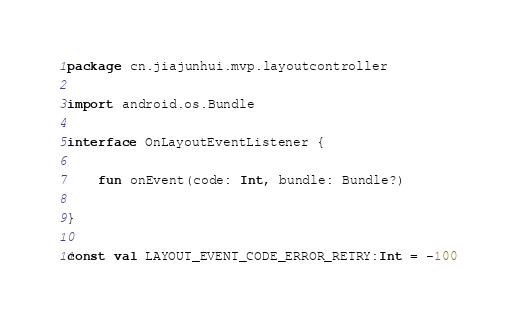Convert code to text. <code><loc_0><loc_0><loc_500><loc_500><_Kotlin_>package cn.jiajunhui.mvp.layoutcontroller

import android.os.Bundle

interface OnLayoutEventListener {

    fun onEvent(code: Int, bundle: Bundle?)

}

const val LAYOUT_EVENT_CODE_ERROR_RETRY:Int = -100</code> 